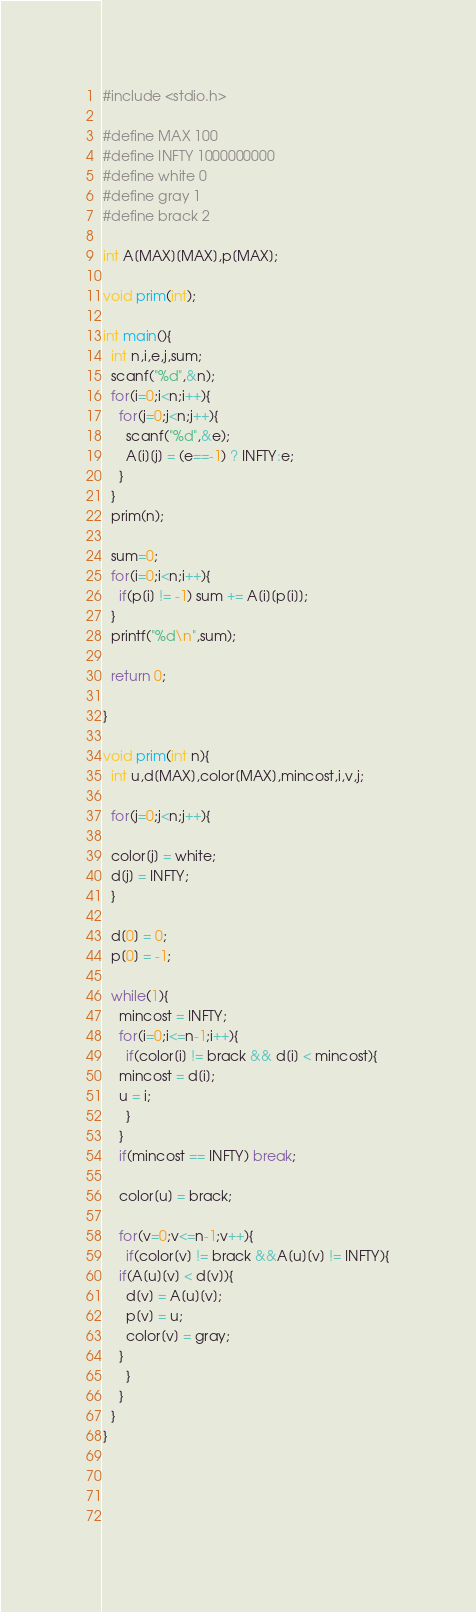<code> <loc_0><loc_0><loc_500><loc_500><_C_>#include <stdio.h>

#define MAX 100
#define INFTY 1000000000
#define white 0
#define gray 1
#define brack 2

int A[MAX][MAX],p[MAX];

void prim(int);

int main(){
  int n,i,e,j,sum;
  scanf("%d",&n);
  for(i=0;i<n;i++){
    for(j=0;j<n;j++){
      scanf("%d",&e);
      A[i][j] = (e==-1) ? INFTY:e;
    }
  }
  prim(n);

  sum=0;
  for(i=0;i<n;i++){
    if(p[i] != -1) sum += A[i][p[i]];
  }
  printf("%d\n",sum);

  return 0;
  
}

void prim(int n){
  int u,d[MAX],color[MAX],mincost,i,v,j;

  for(j=0;j<n;j++){

  color[j] = white;
  d[j] = INFTY;
  }

  d[0] = 0;
  p[0] = -1;

  while(1){
    mincost = INFTY;
    for(i=0;i<=n-1;i++){
      if(color[i] != brack && d[i] < mincost){
	mincost = d[i];
	u = i;
      }
    }
    if(mincost == INFTY) break;

    color[u] = brack;

    for(v=0;v<=n-1;v++){
      if(color[v] != brack &&A[u][v] != INFTY){
	if(A[u][v] < d[v]){
	  d[v] = A[u][v];
	  p[v] = u;
	  color[v] = gray;
	}
      }
    }
  }
}

      
    
  

</code> 